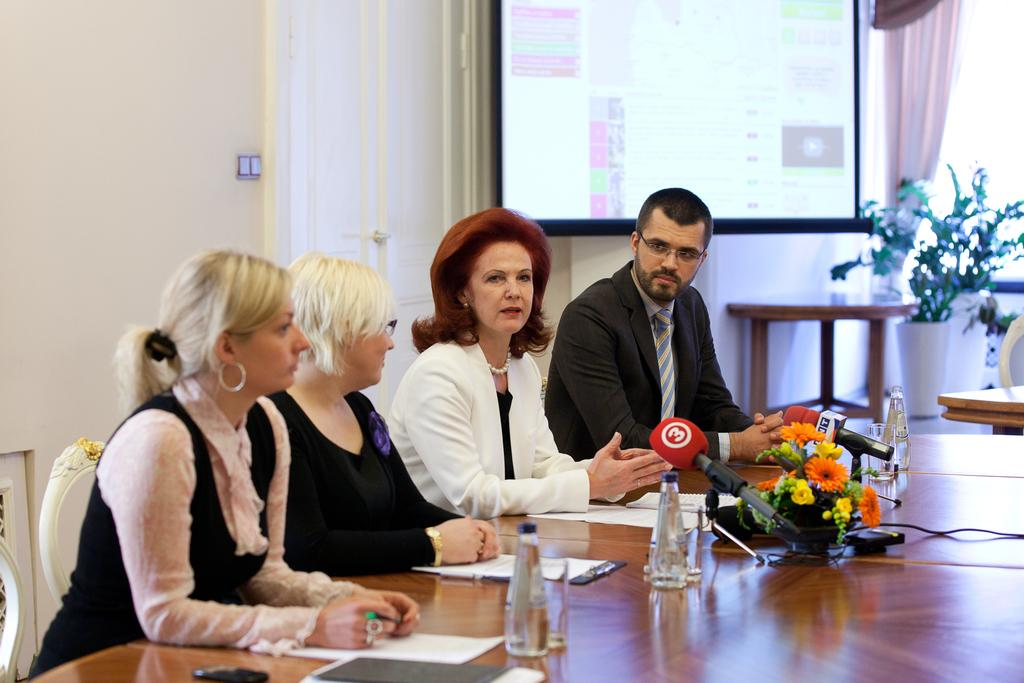How many people are present in the image? There are three women and three men in the image, making a total of six people. What are the women and men doing in the image? The women and men are sitting on chairs. What is in front of the chairs? There is a table in front of the chairs. What type of building can be seen in the background of the image? There is no building visible in the image; it only shows the women, men, chairs, and table. How many legs does the fifth person have in the image? There is no fifth person in the image, so it is not possible to determine the number of legs they might have. 